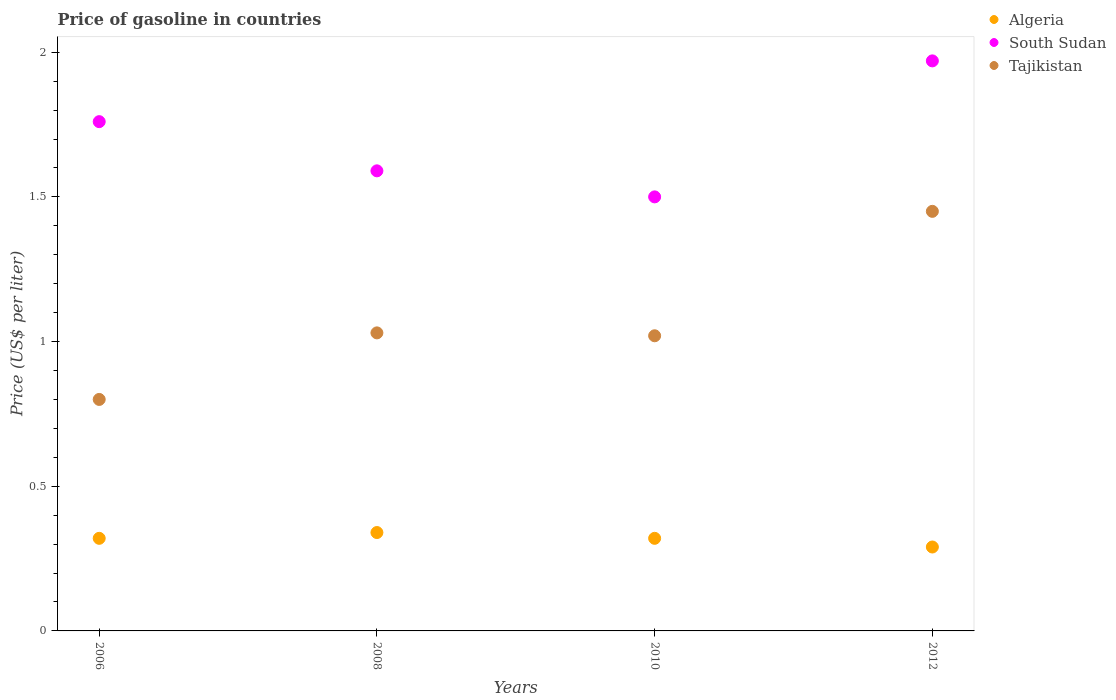Is the number of dotlines equal to the number of legend labels?
Provide a short and direct response. Yes. Across all years, what is the maximum price of gasoline in Algeria?
Make the answer very short. 0.34. Across all years, what is the minimum price of gasoline in Tajikistan?
Your answer should be compact. 0.8. In which year was the price of gasoline in South Sudan maximum?
Provide a short and direct response. 2012. What is the total price of gasoline in Algeria in the graph?
Provide a succinct answer. 1.27. What is the difference between the price of gasoline in Tajikistan in 2008 and that in 2012?
Give a very brief answer. -0.42. What is the difference between the price of gasoline in Tajikistan in 2006 and the price of gasoline in South Sudan in 2008?
Ensure brevity in your answer.  -0.79. What is the average price of gasoline in Tajikistan per year?
Keep it short and to the point. 1.07. In the year 2008, what is the difference between the price of gasoline in South Sudan and price of gasoline in Algeria?
Ensure brevity in your answer.  1.25. What is the ratio of the price of gasoline in Algeria in 2008 to that in 2012?
Make the answer very short. 1.17. Is the price of gasoline in Algeria in 2006 less than that in 2010?
Your answer should be very brief. No. Is the difference between the price of gasoline in South Sudan in 2008 and 2010 greater than the difference between the price of gasoline in Algeria in 2008 and 2010?
Provide a short and direct response. Yes. What is the difference between the highest and the second highest price of gasoline in Algeria?
Keep it short and to the point. 0.02. What is the difference between the highest and the lowest price of gasoline in Tajikistan?
Make the answer very short. 0.65. In how many years, is the price of gasoline in South Sudan greater than the average price of gasoline in South Sudan taken over all years?
Provide a succinct answer. 2. Is it the case that in every year, the sum of the price of gasoline in South Sudan and price of gasoline in Tajikistan  is greater than the price of gasoline in Algeria?
Your response must be concise. Yes. Does the price of gasoline in Algeria monotonically increase over the years?
Your answer should be very brief. No. Is the price of gasoline in Tajikistan strictly greater than the price of gasoline in South Sudan over the years?
Your response must be concise. No. How many dotlines are there?
Offer a terse response. 3. Does the graph contain any zero values?
Ensure brevity in your answer.  No. Does the graph contain grids?
Give a very brief answer. No. What is the title of the graph?
Your response must be concise. Price of gasoline in countries. What is the label or title of the X-axis?
Give a very brief answer. Years. What is the label or title of the Y-axis?
Provide a succinct answer. Price (US$ per liter). What is the Price (US$ per liter) of Algeria in 2006?
Offer a terse response. 0.32. What is the Price (US$ per liter) of South Sudan in 2006?
Give a very brief answer. 1.76. What is the Price (US$ per liter) of Algeria in 2008?
Provide a short and direct response. 0.34. What is the Price (US$ per liter) of South Sudan in 2008?
Give a very brief answer. 1.59. What is the Price (US$ per liter) of Tajikistan in 2008?
Offer a terse response. 1.03. What is the Price (US$ per liter) of Algeria in 2010?
Your response must be concise. 0.32. What is the Price (US$ per liter) of South Sudan in 2010?
Your answer should be very brief. 1.5. What is the Price (US$ per liter) of Tajikistan in 2010?
Keep it short and to the point. 1.02. What is the Price (US$ per liter) in Algeria in 2012?
Keep it short and to the point. 0.29. What is the Price (US$ per liter) in South Sudan in 2012?
Keep it short and to the point. 1.97. What is the Price (US$ per liter) in Tajikistan in 2012?
Give a very brief answer. 1.45. Across all years, what is the maximum Price (US$ per liter) of Algeria?
Make the answer very short. 0.34. Across all years, what is the maximum Price (US$ per liter) in South Sudan?
Make the answer very short. 1.97. Across all years, what is the maximum Price (US$ per liter) of Tajikistan?
Your response must be concise. 1.45. Across all years, what is the minimum Price (US$ per liter) in Algeria?
Make the answer very short. 0.29. Across all years, what is the minimum Price (US$ per liter) of Tajikistan?
Your answer should be compact. 0.8. What is the total Price (US$ per liter) of Algeria in the graph?
Give a very brief answer. 1.27. What is the total Price (US$ per liter) of South Sudan in the graph?
Provide a short and direct response. 6.82. What is the difference between the Price (US$ per liter) in Algeria in 2006 and that in 2008?
Keep it short and to the point. -0.02. What is the difference between the Price (US$ per liter) of South Sudan in 2006 and that in 2008?
Your response must be concise. 0.17. What is the difference between the Price (US$ per liter) of Tajikistan in 2006 and that in 2008?
Your answer should be compact. -0.23. What is the difference between the Price (US$ per liter) of Algeria in 2006 and that in 2010?
Offer a very short reply. 0. What is the difference between the Price (US$ per liter) in South Sudan in 2006 and that in 2010?
Ensure brevity in your answer.  0.26. What is the difference between the Price (US$ per liter) of Tajikistan in 2006 and that in 2010?
Keep it short and to the point. -0.22. What is the difference between the Price (US$ per liter) of Algeria in 2006 and that in 2012?
Give a very brief answer. 0.03. What is the difference between the Price (US$ per liter) of South Sudan in 2006 and that in 2012?
Give a very brief answer. -0.21. What is the difference between the Price (US$ per liter) of Tajikistan in 2006 and that in 2012?
Give a very brief answer. -0.65. What is the difference between the Price (US$ per liter) of South Sudan in 2008 and that in 2010?
Offer a terse response. 0.09. What is the difference between the Price (US$ per liter) of South Sudan in 2008 and that in 2012?
Provide a short and direct response. -0.38. What is the difference between the Price (US$ per liter) in Tajikistan in 2008 and that in 2012?
Provide a short and direct response. -0.42. What is the difference between the Price (US$ per liter) in Algeria in 2010 and that in 2012?
Provide a succinct answer. 0.03. What is the difference between the Price (US$ per liter) in South Sudan in 2010 and that in 2012?
Ensure brevity in your answer.  -0.47. What is the difference between the Price (US$ per liter) of Tajikistan in 2010 and that in 2012?
Offer a very short reply. -0.43. What is the difference between the Price (US$ per liter) in Algeria in 2006 and the Price (US$ per liter) in South Sudan in 2008?
Ensure brevity in your answer.  -1.27. What is the difference between the Price (US$ per liter) in Algeria in 2006 and the Price (US$ per liter) in Tajikistan in 2008?
Provide a short and direct response. -0.71. What is the difference between the Price (US$ per liter) of South Sudan in 2006 and the Price (US$ per liter) of Tajikistan in 2008?
Provide a succinct answer. 0.73. What is the difference between the Price (US$ per liter) in Algeria in 2006 and the Price (US$ per liter) in South Sudan in 2010?
Keep it short and to the point. -1.18. What is the difference between the Price (US$ per liter) in Algeria in 2006 and the Price (US$ per liter) in Tajikistan in 2010?
Offer a terse response. -0.7. What is the difference between the Price (US$ per liter) in South Sudan in 2006 and the Price (US$ per liter) in Tajikistan in 2010?
Offer a very short reply. 0.74. What is the difference between the Price (US$ per liter) in Algeria in 2006 and the Price (US$ per liter) in South Sudan in 2012?
Ensure brevity in your answer.  -1.65. What is the difference between the Price (US$ per liter) in Algeria in 2006 and the Price (US$ per liter) in Tajikistan in 2012?
Offer a terse response. -1.13. What is the difference between the Price (US$ per liter) in South Sudan in 2006 and the Price (US$ per liter) in Tajikistan in 2012?
Provide a succinct answer. 0.31. What is the difference between the Price (US$ per liter) of Algeria in 2008 and the Price (US$ per liter) of South Sudan in 2010?
Your response must be concise. -1.16. What is the difference between the Price (US$ per liter) in Algeria in 2008 and the Price (US$ per liter) in Tajikistan in 2010?
Offer a very short reply. -0.68. What is the difference between the Price (US$ per liter) in South Sudan in 2008 and the Price (US$ per liter) in Tajikistan in 2010?
Give a very brief answer. 0.57. What is the difference between the Price (US$ per liter) in Algeria in 2008 and the Price (US$ per liter) in South Sudan in 2012?
Ensure brevity in your answer.  -1.63. What is the difference between the Price (US$ per liter) in Algeria in 2008 and the Price (US$ per liter) in Tajikistan in 2012?
Make the answer very short. -1.11. What is the difference between the Price (US$ per liter) in South Sudan in 2008 and the Price (US$ per liter) in Tajikistan in 2012?
Your answer should be compact. 0.14. What is the difference between the Price (US$ per liter) in Algeria in 2010 and the Price (US$ per liter) in South Sudan in 2012?
Your answer should be compact. -1.65. What is the difference between the Price (US$ per liter) of Algeria in 2010 and the Price (US$ per liter) of Tajikistan in 2012?
Provide a succinct answer. -1.13. What is the average Price (US$ per liter) of Algeria per year?
Your answer should be compact. 0.32. What is the average Price (US$ per liter) of South Sudan per year?
Your answer should be compact. 1.71. What is the average Price (US$ per liter) of Tajikistan per year?
Offer a terse response. 1.07. In the year 2006, what is the difference between the Price (US$ per liter) in Algeria and Price (US$ per liter) in South Sudan?
Your response must be concise. -1.44. In the year 2006, what is the difference between the Price (US$ per liter) in Algeria and Price (US$ per liter) in Tajikistan?
Ensure brevity in your answer.  -0.48. In the year 2006, what is the difference between the Price (US$ per liter) of South Sudan and Price (US$ per liter) of Tajikistan?
Give a very brief answer. 0.96. In the year 2008, what is the difference between the Price (US$ per liter) of Algeria and Price (US$ per liter) of South Sudan?
Your answer should be very brief. -1.25. In the year 2008, what is the difference between the Price (US$ per liter) in Algeria and Price (US$ per liter) in Tajikistan?
Ensure brevity in your answer.  -0.69. In the year 2008, what is the difference between the Price (US$ per liter) in South Sudan and Price (US$ per liter) in Tajikistan?
Offer a very short reply. 0.56. In the year 2010, what is the difference between the Price (US$ per liter) of Algeria and Price (US$ per liter) of South Sudan?
Offer a terse response. -1.18. In the year 2010, what is the difference between the Price (US$ per liter) of Algeria and Price (US$ per liter) of Tajikistan?
Provide a short and direct response. -0.7. In the year 2010, what is the difference between the Price (US$ per liter) in South Sudan and Price (US$ per liter) in Tajikistan?
Offer a very short reply. 0.48. In the year 2012, what is the difference between the Price (US$ per liter) of Algeria and Price (US$ per liter) of South Sudan?
Offer a terse response. -1.68. In the year 2012, what is the difference between the Price (US$ per liter) in Algeria and Price (US$ per liter) in Tajikistan?
Make the answer very short. -1.16. In the year 2012, what is the difference between the Price (US$ per liter) of South Sudan and Price (US$ per liter) of Tajikistan?
Offer a terse response. 0.52. What is the ratio of the Price (US$ per liter) of South Sudan in 2006 to that in 2008?
Your response must be concise. 1.11. What is the ratio of the Price (US$ per liter) in Tajikistan in 2006 to that in 2008?
Offer a very short reply. 0.78. What is the ratio of the Price (US$ per liter) of South Sudan in 2006 to that in 2010?
Provide a short and direct response. 1.17. What is the ratio of the Price (US$ per liter) in Tajikistan in 2006 to that in 2010?
Give a very brief answer. 0.78. What is the ratio of the Price (US$ per liter) of Algeria in 2006 to that in 2012?
Offer a very short reply. 1.1. What is the ratio of the Price (US$ per liter) in South Sudan in 2006 to that in 2012?
Your answer should be very brief. 0.89. What is the ratio of the Price (US$ per liter) of Tajikistan in 2006 to that in 2012?
Provide a succinct answer. 0.55. What is the ratio of the Price (US$ per liter) in South Sudan in 2008 to that in 2010?
Keep it short and to the point. 1.06. What is the ratio of the Price (US$ per liter) of Tajikistan in 2008 to that in 2010?
Provide a succinct answer. 1.01. What is the ratio of the Price (US$ per liter) of Algeria in 2008 to that in 2012?
Provide a succinct answer. 1.17. What is the ratio of the Price (US$ per liter) in South Sudan in 2008 to that in 2012?
Your answer should be compact. 0.81. What is the ratio of the Price (US$ per liter) in Tajikistan in 2008 to that in 2012?
Ensure brevity in your answer.  0.71. What is the ratio of the Price (US$ per liter) of Algeria in 2010 to that in 2012?
Your answer should be compact. 1.1. What is the ratio of the Price (US$ per liter) of South Sudan in 2010 to that in 2012?
Provide a succinct answer. 0.76. What is the ratio of the Price (US$ per liter) in Tajikistan in 2010 to that in 2012?
Offer a very short reply. 0.7. What is the difference between the highest and the second highest Price (US$ per liter) of Algeria?
Your response must be concise. 0.02. What is the difference between the highest and the second highest Price (US$ per liter) in South Sudan?
Offer a terse response. 0.21. What is the difference between the highest and the second highest Price (US$ per liter) in Tajikistan?
Provide a short and direct response. 0.42. What is the difference between the highest and the lowest Price (US$ per liter) of Algeria?
Make the answer very short. 0.05. What is the difference between the highest and the lowest Price (US$ per liter) of South Sudan?
Offer a terse response. 0.47. What is the difference between the highest and the lowest Price (US$ per liter) in Tajikistan?
Ensure brevity in your answer.  0.65. 